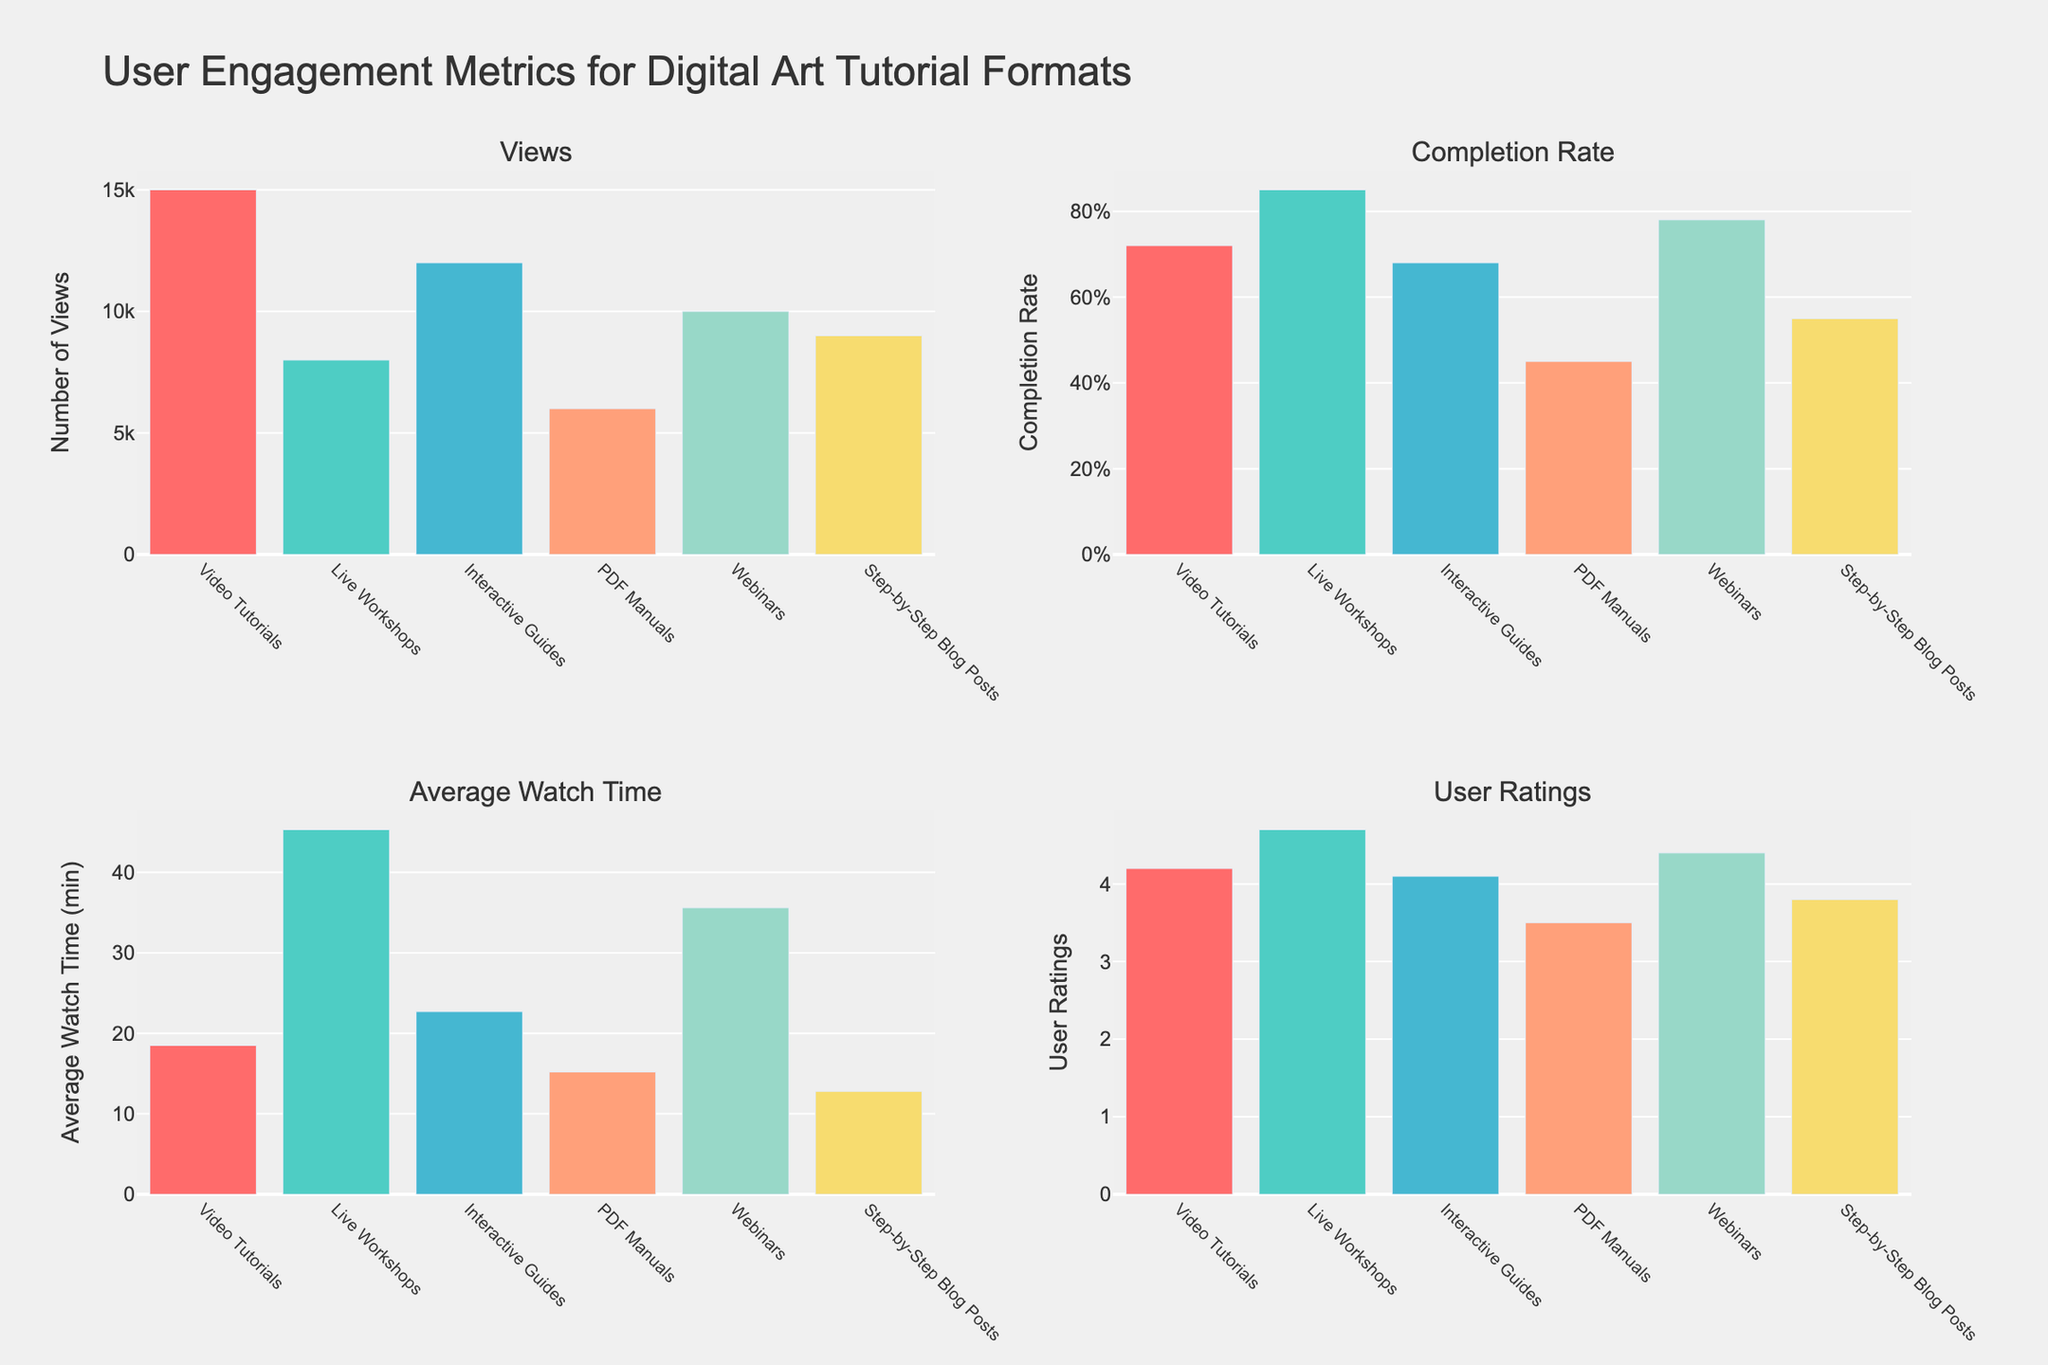What is the title of the figure? The figure's title is typically placed at the top and gives an overview of what the chart is about.
Answer: Annual Low-Cost Eye Surgeries Worldwide by Procedure Type How many different types of eye surgeries are displayed in the figure? Each subplot represents a different type of eye surgery, and counting them will give the number of categories.
Answer: Five Which year had the highest number of cataract surgeries? By looking at the bar lengths in the subplot for cataract surgeries, we can identify the year with the longest bar.
Answer: 2022 What is the total number of Retinal Detachment Repairs performed in 2020 and 2021 combined? Sum the numbers for Retinal Detachment Repairs in the given years: 85,000 (2020) + 102,000 (2021).
Answer: 187,000 Compare the number of Glaucoma surgeries performed in 2019 and 2020. Which year had more, and by how many? Subtract the number of surgeries in 2020 from those in 2019: 610,000 (2019) - 520,000 (2020).
Answer: 2019 had 90,000 more surgeries What’s the average number of corneal transplants performed annually from 2018 to 2022? Sum the number of Corneal Transplants for each year and divide by the number of years: (185,000 + 195,000 + 160,000 + 210,000 + 225,000) / 5.
Answer: 195,000 Which type of surgery shows a consistent increase in the number of procedures every year? Look at the trends in each subplot to identify which one shows a consistent year-on-year increase.
Answer: Cataract Surgery and Strabismus Correction Is the trend in the number of cataract surgeries similar to that of glaucoma surgeries from 2018 to 2022? Compare the bar lengths in both subplots for each year to identify similar trends.
Answer: No, cataract surgeries show a consistent increase, whereas glaucoma surgeries slightly decrease in 2020 Calculate the percentage increase in the number of cataract surgeries from 2020 to 2021. Subtract the number of surgeries in 2020 from 2021, divide by the 2020 value, and multiply by 100: ((3,600,000 - 2,900,000) / 2,900,000) * 100.
Answer: 24.14% What is the least performed eye surgery in 2022? Look for the shortest bar in the 2022 categories across all subplots.
Answer: Retinal Detachment Repair 